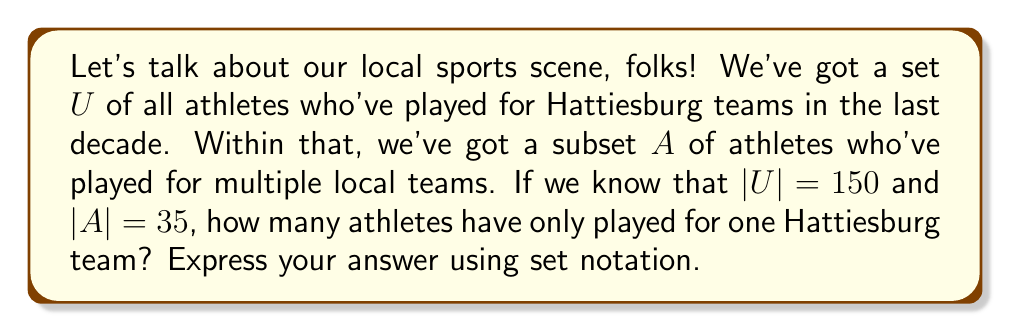What is the answer to this math problem? Alright, sports fans, let's break this down step-by-step:

1) We're dealing with the universal set $U$, which contains all athletes who've played for Hattiesburg teams in the last decade. We're told that $|U| = 150$.

2) Set $A$ is a subset of $U$, containing athletes who've played for multiple local teams. We're given that $|A| = 35$.

3) What we're looking for is the complement of set $A$ within the universal set $U$. In set theory, we denote this as $A^c$ or $U \setminus A$.

4) The complement $A^c$ represents all elements in $U$ that are not in $A$. In our context, these are the athletes who have only played for one Hattiesburg team.

5) To find the number of elements in $A^c$, we can use the formula:

   $$|A^c| = |U| - |A|$$

6) Plugging in our known values:

   $$|A^c| = 150 - 35 = 115$$

Therefore, 115 athletes have only played for one Hattiesburg team.

7) To express this using set notation, we write:

   $$|U \setminus A| = 115$$

   This reads as "the cardinality (number of elements) of the set $U$ minus $A$ is 115".
Answer: $$|U \setminus A| = 115$$ 